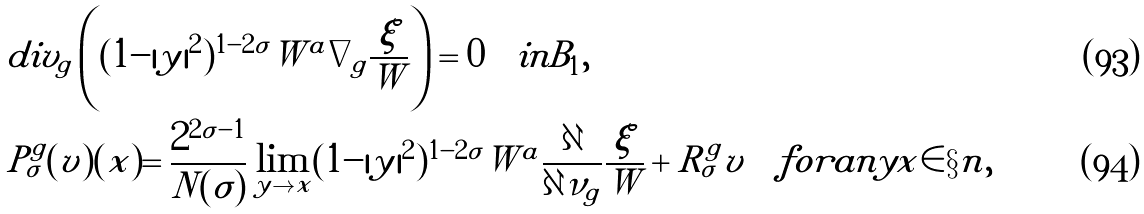Convert formula to latex. <formula><loc_0><loc_0><loc_500><loc_500>& d i v _ { \tilde { g } } \left ( ( 1 - | y | ^ { 2 } ) ^ { 1 - 2 \sigma } \tilde { W } ^ { a } \nabla _ { \tilde { g } } \frac { \tilde { \xi } } { \tilde { W } } \right ) = 0 \quad i n B _ { 1 } , \\ & P ^ { g } _ { \sigma } ( v ) ( x ) = \frac { 2 ^ { 2 \sigma - 1 } } { N ( \sigma ) } \lim _ { y \to x } ( 1 - | y | ^ { 2 } ) ^ { 1 - 2 \sigma } \tilde { W } ^ { a } \frac { \partial } { \partial \nu _ { \tilde { g } } } \frac { \tilde { \xi } } { \tilde { W } } + R _ { \sigma } ^ { g } v \quad f o r a n y x \in \S n ,</formula> 